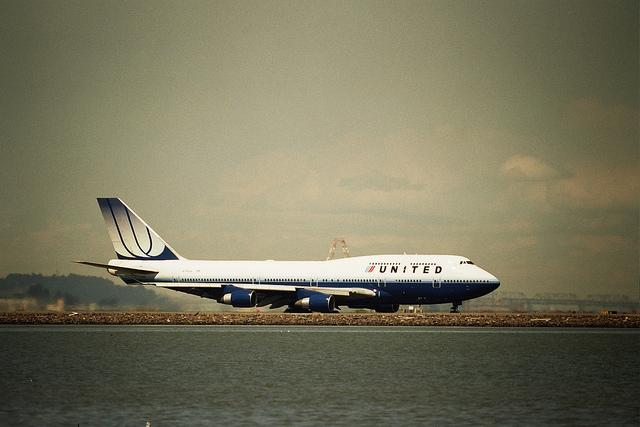What is the name of this airline?
Give a very brief answer. United. Why is the plane flying low?
Short answer required. Landing. What is in the sky?
Concise answer only. Plane. Is the plane floating in the water?
Be succinct. No. Is the plane on the ground?
Give a very brief answer. Yes. 